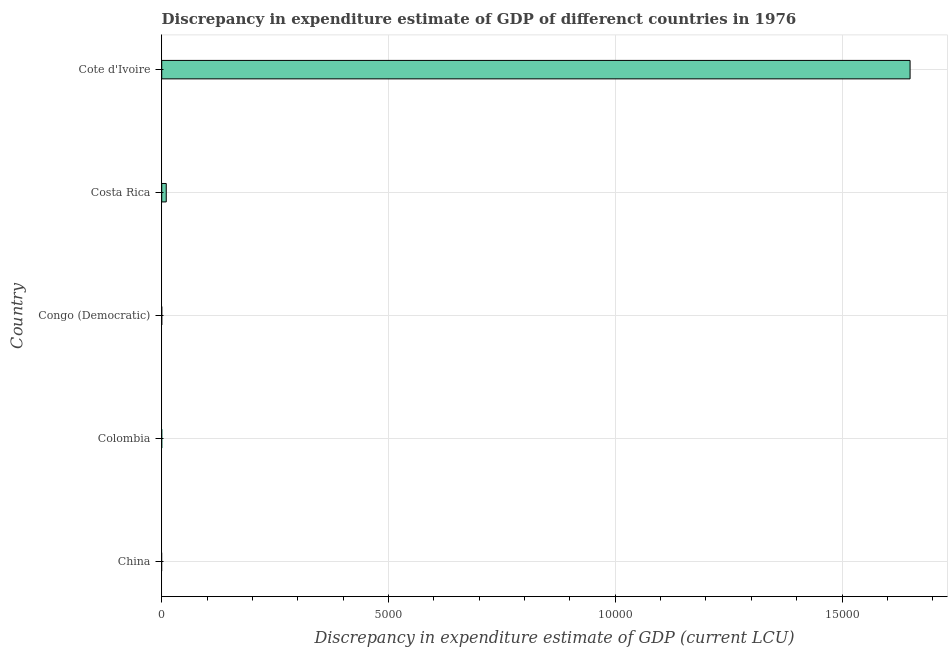Does the graph contain any zero values?
Offer a terse response. Yes. What is the title of the graph?
Your response must be concise. Discrepancy in expenditure estimate of GDP of differenct countries in 1976. What is the label or title of the X-axis?
Offer a terse response. Discrepancy in expenditure estimate of GDP (current LCU). What is the label or title of the Y-axis?
Give a very brief answer. Country. Across all countries, what is the maximum discrepancy in expenditure estimate of gdp?
Your answer should be compact. 1.65e+04. Across all countries, what is the minimum discrepancy in expenditure estimate of gdp?
Offer a very short reply. 0. In which country was the discrepancy in expenditure estimate of gdp maximum?
Your answer should be very brief. Cote d'Ivoire. What is the sum of the discrepancy in expenditure estimate of gdp?
Your answer should be compact. 1.66e+04. What is the difference between the discrepancy in expenditure estimate of gdp in Costa Rica and Cote d'Ivoire?
Your response must be concise. -1.64e+04. What is the average discrepancy in expenditure estimate of gdp per country?
Make the answer very short. 3320. In how many countries, is the discrepancy in expenditure estimate of gdp greater than 9000 LCU?
Make the answer very short. 1. What is the difference between the highest and the lowest discrepancy in expenditure estimate of gdp?
Offer a terse response. 1.65e+04. How many bars are there?
Offer a very short reply. 2. How many countries are there in the graph?
Make the answer very short. 5. What is the difference between two consecutive major ticks on the X-axis?
Make the answer very short. 5000. What is the Discrepancy in expenditure estimate of GDP (current LCU) in Colombia?
Your answer should be compact. 0. What is the Discrepancy in expenditure estimate of GDP (current LCU) of Costa Rica?
Your answer should be compact. 100. What is the Discrepancy in expenditure estimate of GDP (current LCU) in Cote d'Ivoire?
Provide a short and direct response. 1.65e+04. What is the difference between the Discrepancy in expenditure estimate of GDP (current LCU) in Costa Rica and Cote d'Ivoire?
Your answer should be very brief. -1.64e+04. What is the ratio of the Discrepancy in expenditure estimate of GDP (current LCU) in Costa Rica to that in Cote d'Ivoire?
Make the answer very short. 0.01. 